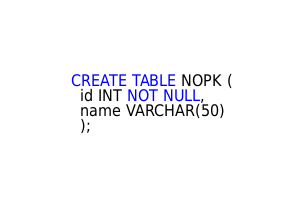Convert code to text. <code><loc_0><loc_0><loc_500><loc_500><_SQL_>CREATE TABLE NOPK (
  id INT NOT NULL,
  name VARCHAR(50)
  );</code> 